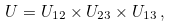<formula> <loc_0><loc_0><loc_500><loc_500>U = U _ { 1 2 } \times U _ { 2 3 } \times U _ { 1 3 } \, ,</formula> 